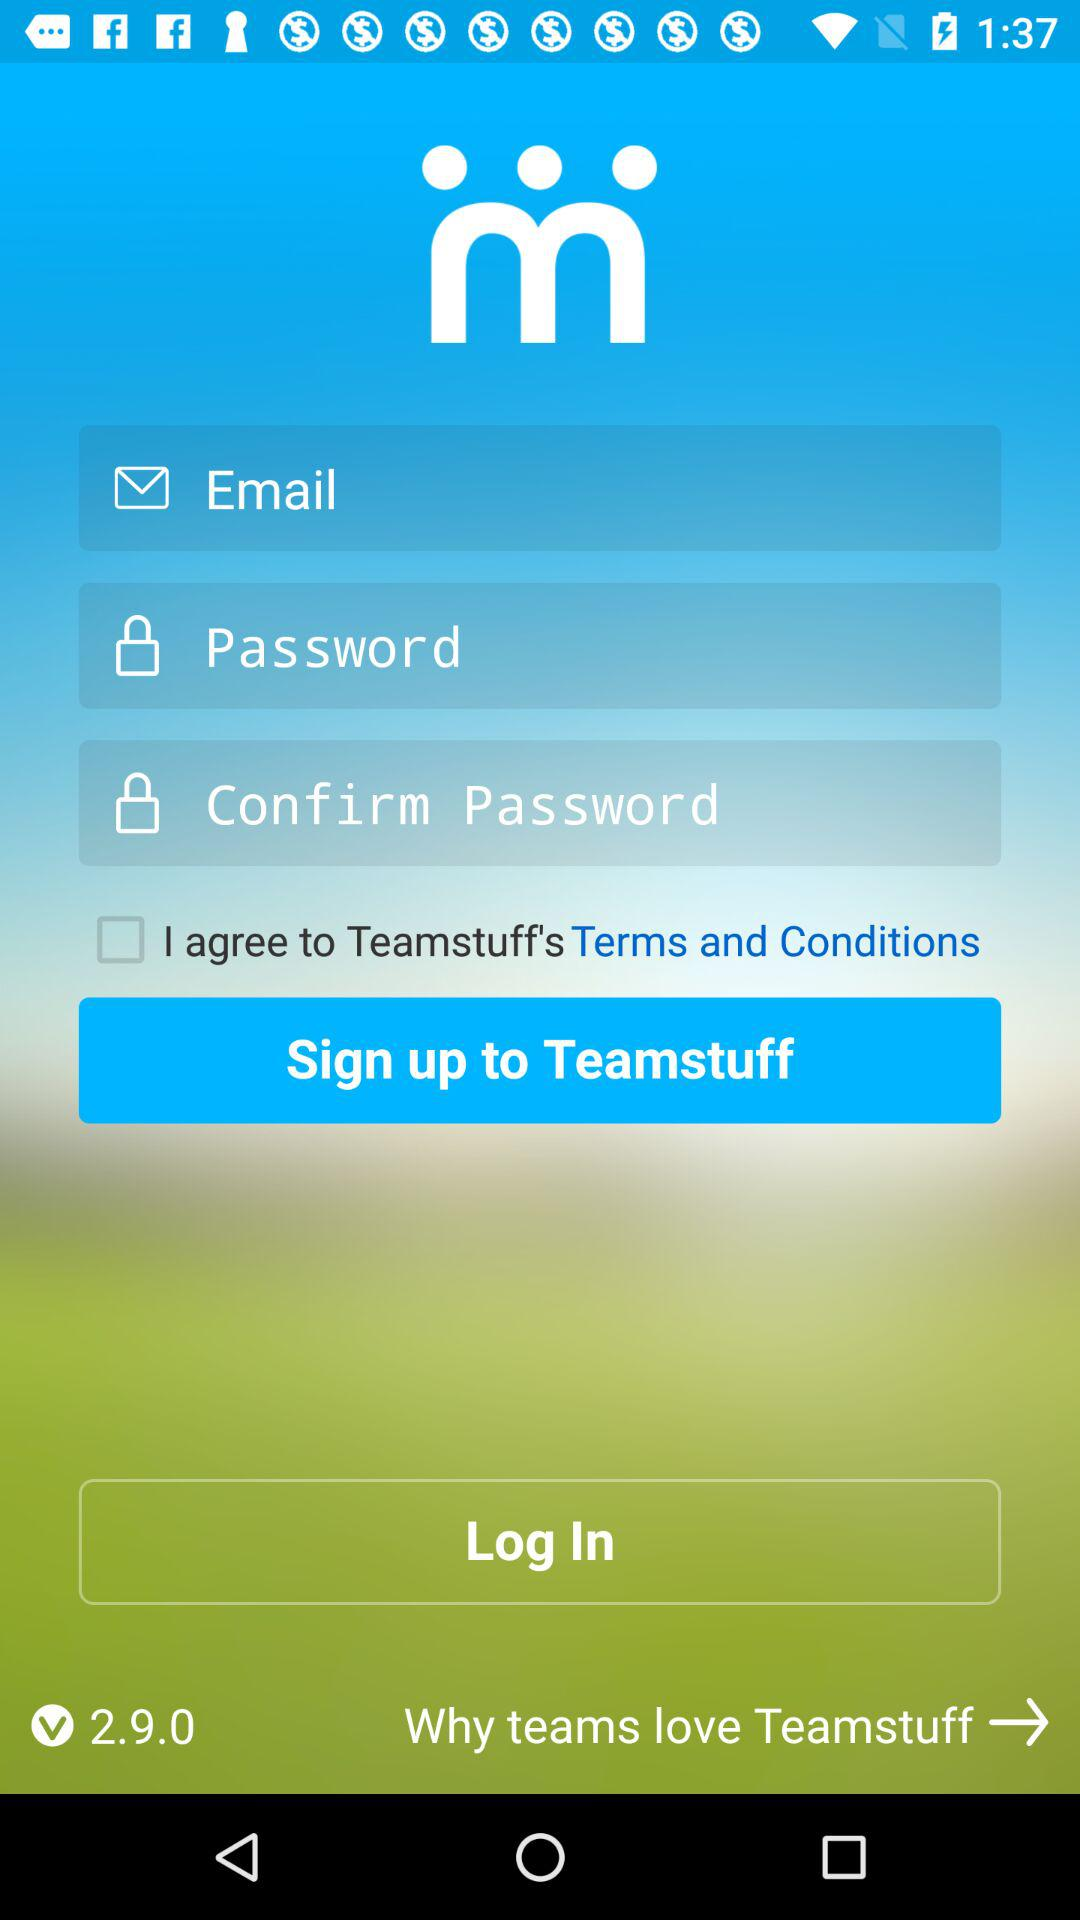What is the version of the application? The version is 2.9.0. 